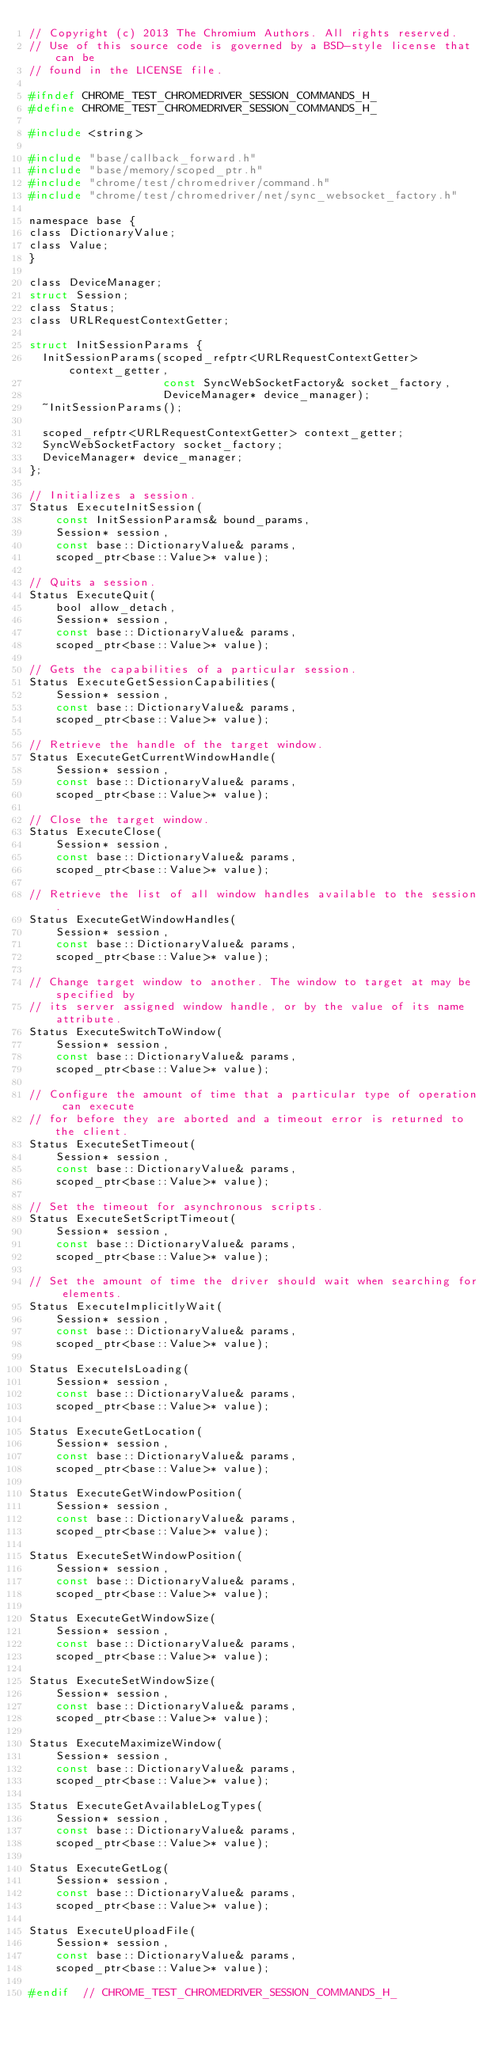<code> <loc_0><loc_0><loc_500><loc_500><_C_>// Copyright (c) 2013 The Chromium Authors. All rights reserved.
// Use of this source code is governed by a BSD-style license that can be
// found in the LICENSE file.

#ifndef CHROME_TEST_CHROMEDRIVER_SESSION_COMMANDS_H_
#define CHROME_TEST_CHROMEDRIVER_SESSION_COMMANDS_H_

#include <string>

#include "base/callback_forward.h"
#include "base/memory/scoped_ptr.h"
#include "chrome/test/chromedriver/command.h"
#include "chrome/test/chromedriver/net/sync_websocket_factory.h"

namespace base {
class DictionaryValue;
class Value;
}

class DeviceManager;
struct Session;
class Status;
class URLRequestContextGetter;

struct InitSessionParams {
  InitSessionParams(scoped_refptr<URLRequestContextGetter> context_getter,
                    const SyncWebSocketFactory& socket_factory,
                    DeviceManager* device_manager);
  ~InitSessionParams();

  scoped_refptr<URLRequestContextGetter> context_getter;
  SyncWebSocketFactory socket_factory;
  DeviceManager* device_manager;
};

// Initializes a session.
Status ExecuteInitSession(
    const InitSessionParams& bound_params,
    Session* session,
    const base::DictionaryValue& params,
    scoped_ptr<base::Value>* value);

// Quits a session.
Status ExecuteQuit(
    bool allow_detach,
    Session* session,
    const base::DictionaryValue& params,
    scoped_ptr<base::Value>* value);

// Gets the capabilities of a particular session.
Status ExecuteGetSessionCapabilities(
    Session* session,
    const base::DictionaryValue& params,
    scoped_ptr<base::Value>* value);

// Retrieve the handle of the target window.
Status ExecuteGetCurrentWindowHandle(
    Session* session,
    const base::DictionaryValue& params,
    scoped_ptr<base::Value>* value);

// Close the target window.
Status ExecuteClose(
    Session* session,
    const base::DictionaryValue& params,
    scoped_ptr<base::Value>* value);

// Retrieve the list of all window handles available to the session.
Status ExecuteGetWindowHandles(
    Session* session,
    const base::DictionaryValue& params,
    scoped_ptr<base::Value>* value);

// Change target window to another. The window to target at may be specified by
// its server assigned window handle, or by the value of its name attribute.
Status ExecuteSwitchToWindow(
    Session* session,
    const base::DictionaryValue& params,
    scoped_ptr<base::Value>* value);

// Configure the amount of time that a particular type of operation can execute
// for before they are aborted and a timeout error is returned to the client.
Status ExecuteSetTimeout(
    Session* session,
    const base::DictionaryValue& params,
    scoped_ptr<base::Value>* value);

// Set the timeout for asynchronous scripts.
Status ExecuteSetScriptTimeout(
    Session* session,
    const base::DictionaryValue& params,
    scoped_ptr<base::Value>* value);

// Set the amount of time the driver should wait when searching for elements.
Status ExecuteImplicitlyWait(
    Session* session,
    const base::DictionaryValue& params,
    scoped_ptr<base::Value>* value);

Status ExecuteIsLoading(
    Session* session,
    const base::DictionaryValue& params,
    scoped_ptr<base::Value>* value);

Status ExecuteGetLocation(
    Session* session,
    const base::DictionaryValue& params,
    scoped_ptr<base::Value>* value);

Status ExecuteGetWindowPosition(
    Session* session,
    const base::DictionaryValue& params,
    scoped_ptr<base::Value>* value);

Status ExecuteSetWindowPosition(
    Session* session,
    const base::DictionaryValue& params,
    scoped_ptr<base::Value>* value);

Status ExecuteGetWindowSize(
    Session* session,
    const base::DictionaryValue& params,
    scoped_ptr<base::Value>* value);

Status ExecuteSetWindowSize(
    Session* session,
    const base::DictionaryValue& params,
    scoped_ptr<base::Value>* value);

Status ExecuteMaximizeWindow(
    Session* session,
    const base::DictionaryValue& params,
    scoped_ptr<base::Value>* value);

Status ExecuteGetAvailableLogTypes(
    Session* session,
    const base::DictionaryValue& params,
    scoped_ptr<base::Value>* value);

Status ExecuteGetLog(
    Session* session,
    const base::DictionaryValue& params,
    scoped_ptr<base::Value>* value);

Status ExecuteUploadFile(
    Session* session,
    const base::DictionaryValue& params,
    scoped_ptr<base::Value>* value);

#endif  // CHROME_TEST_CHROMEDRIVER_SESSION_COMMANDS_H_
</code> 